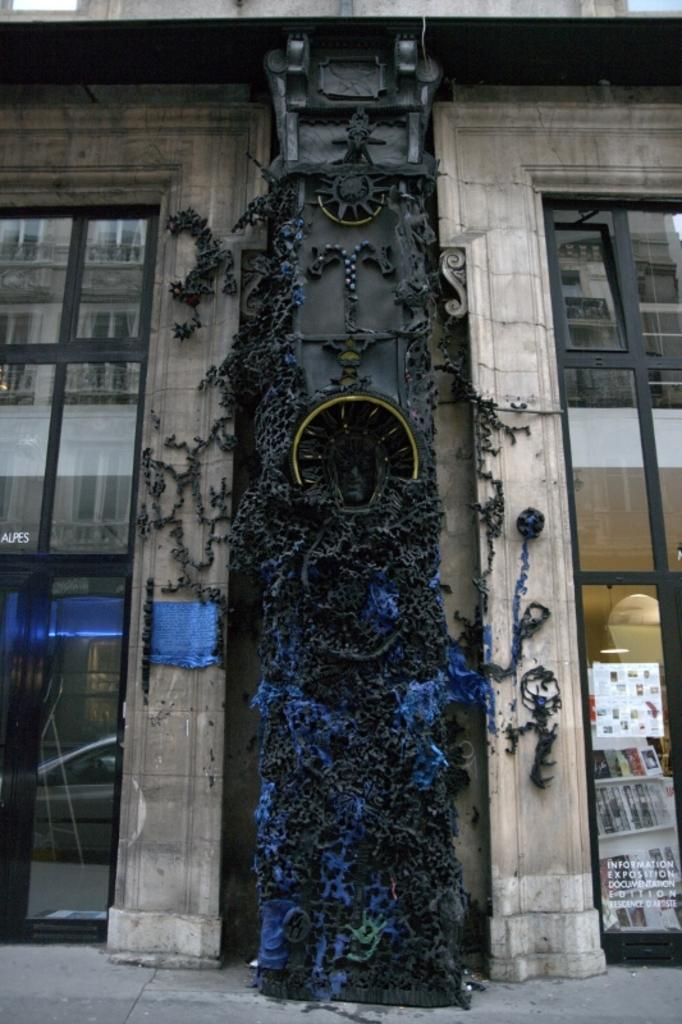What is the main subject in the image? There is a statue in the image. What other structures or objects can be seen in the image? There is a building in the image. What feature of the building is mentioned in the facts? The building has windows. Can you describe the paper in the image? There is a paper on a window in the image. What type of items are placed in shelves in the image? There is a group of books placed in shelves in the image. What type of furniture is present in the image? There is no furniture mentioned in the provided facts. 